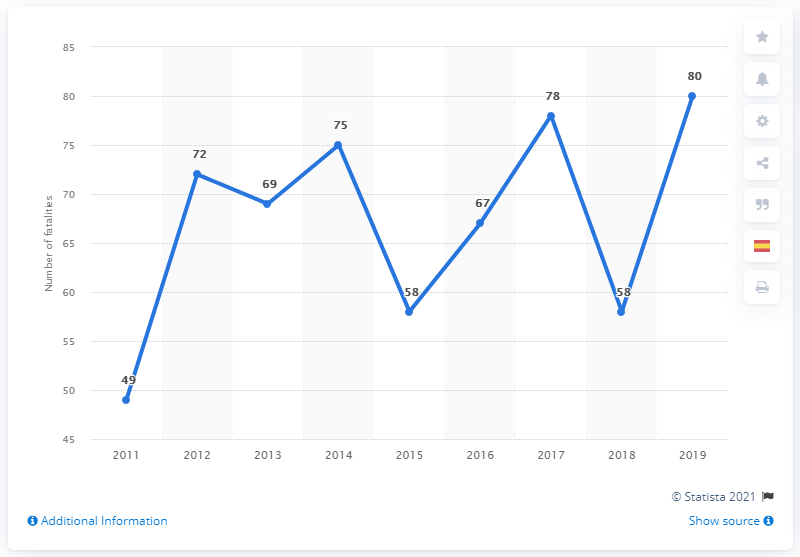Indicate a few pertinent items in this graphic. In 2011, a total of 49 cyclists were killed. In 2019, 80 cyclists lost their lives in fatal traffic accidents in Spain. 